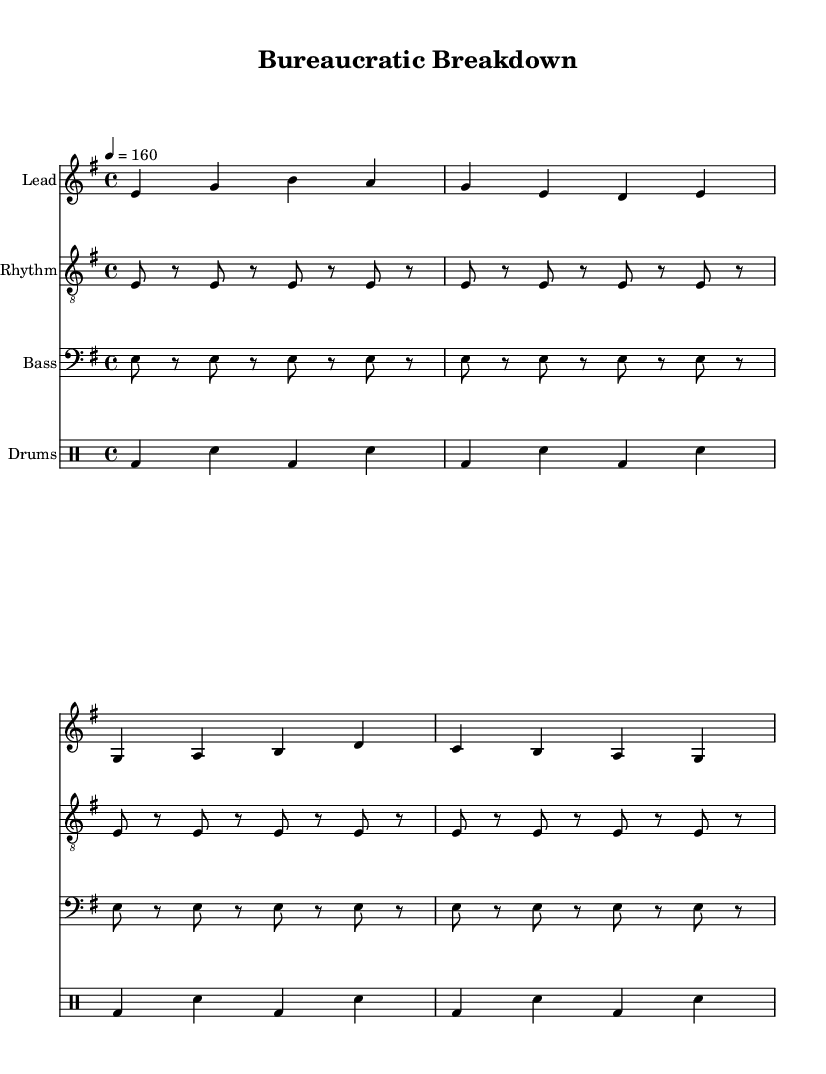What is the key signature of this music? The key signature is indicated by the accidentals at the beginning of the staff. In this case, it shows one sharp, so the key signature is E minor.
Answer: E minor What is the time signature of the piece? The time signature appears at the beginning of the music sheet, which shows a four over four notation, indicating it's in common time, also known as 4/4.
Answer: 4/4 What is the tempo marking for this music? The tempo is written on the music score, indicated by "4 = 160," meaning the quarter note is to be played at a speed of 160 beats per minute.
Answer: 160 How many measures does the verse section have? The verse is composed of a series of notes divided into measures. Analyzing the notes, the verse has a total of 2 measures.
Answer: 2 What is the primary theme of the chorus lyrics? The lyrics of the chorus center around themes of rebellion and breaking free from societal constraints, specifically mentioning bureaucracy and breaking down walls, indicating a desire for freedom.
Answer: Breaking down bureaucracy What instruments are featured in the composition? The sheet music outlines four staves, specifically for Lead, Rhythm, Bass, and Drums, illustrating the instruments used in this piece.
Answer: Lead, Rhythm, Bass, Drums What type of rhythm does the drum part primarily feature? The drum part is comprised of a repeating bass drum and snare pattern, showing a standard punk rock driving rhythm which supports the energetic style typical of the genre.
Answer: Bass drum and snare 